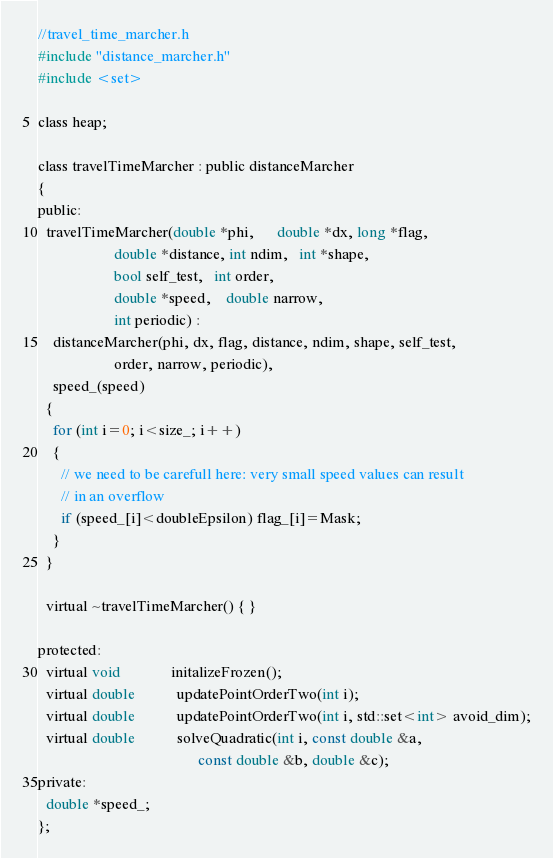<code> <loc_0><loc_0><loc_500><loc_500><_C_>//travel_time_marcher.h
#include "distance_marcher.h"
#include <set>

class heap;

class travelTimeMarcher : public distanceMarcher
{
public:
  travelTimeMarcher(double *phi,      double *dx, long *flag,
                    double *distance, int ndim,   int *shape,
                    bool self_test,   int order,
                    double *speed,    double narrow,
                    int periodic) :
    distanceMarcher(phi, dx, flag, distance, ndim, shape, self_test,
                    order, narrow, periodic),
    speed_(speed)
  {
    for (int i=0; i<size_; i++)
    {
      // we need to be carefull here: very small speed values can result
      // in an overflow
      if (speed_[i]<doubleEpsilon) flag_[i]=Mask;
    }
  }

  virtual ~travelTimeMarcher() { }

protected:
  virtual void             initalizeFrozen();
  virtual double           updatePointOrderTwo(int i);
  virtual double           updatePointOrderTwo(int i, std::set<int> avoid_dim);
  virtual double           solveQuadratic(int i, const double &a,
                                          const double &b, double &c);
private:
  double *speed_;
};
</code> 